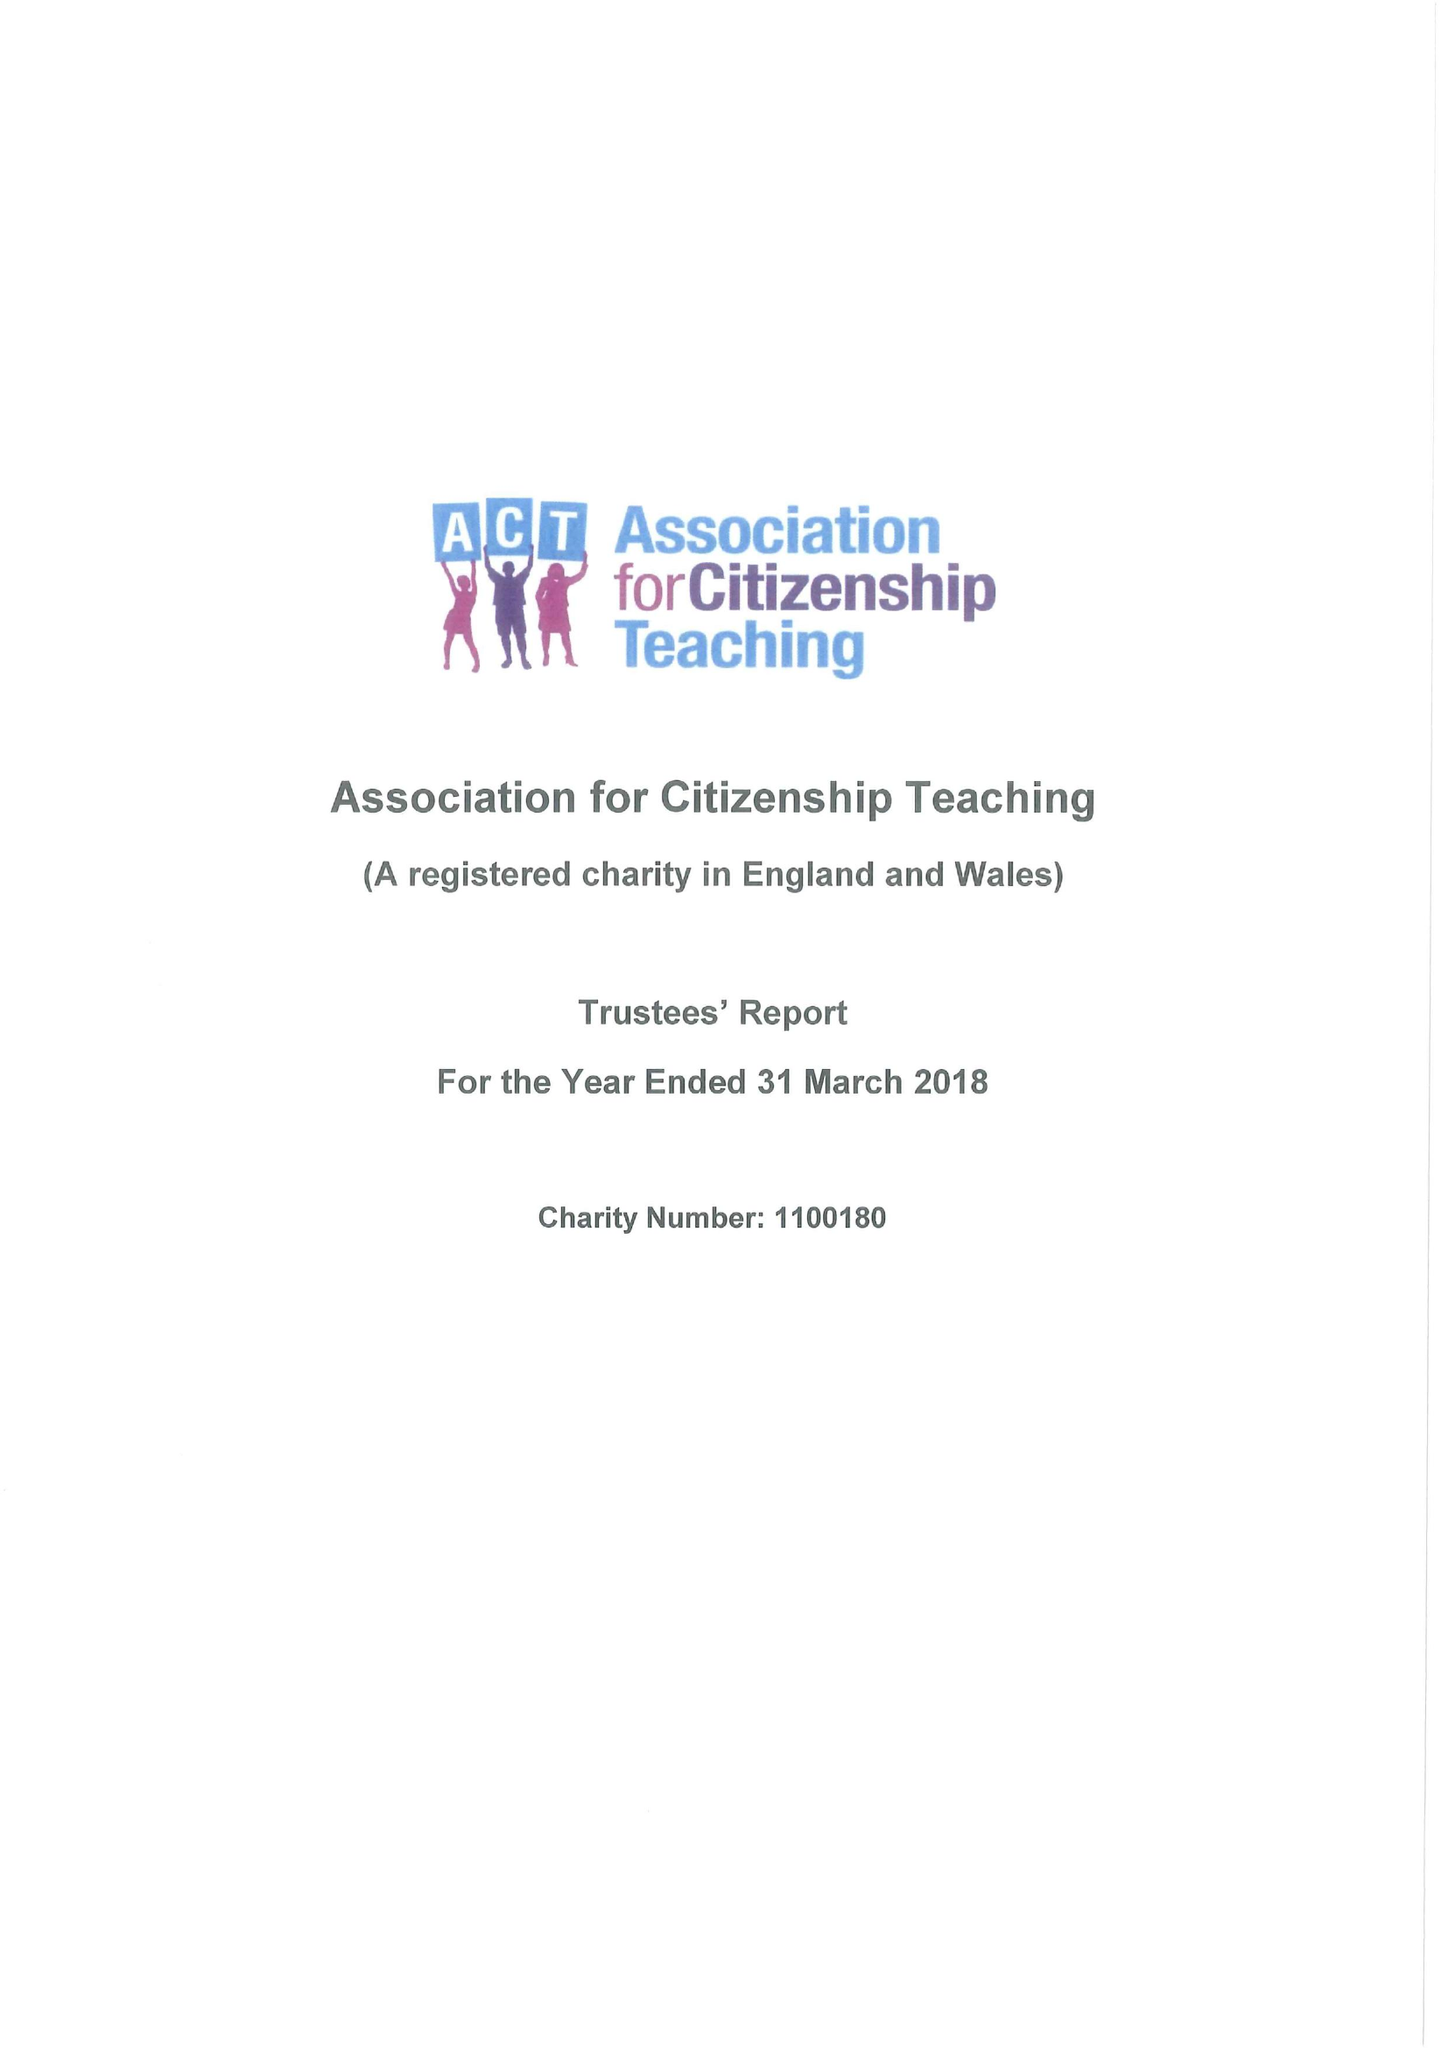What is the value for the address__street_line?
Answer the question using a single word or phrase. 76 VINCENT SQUARE 